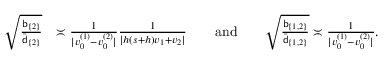<formula> <loc_0><loc_0><loc_500><loc_500>\begin{array} { r l } { \sqrt { \frac { b _ { \{ 2 \} } } { \bar { d } _ { \{ 2 \} } } } } & { \asymp \frac { 1 } { | v _ { 0 } ^ { ( 1 ) } - v _ { 0 } ^ { ( 2 ) } | } \frac { 1 } { | h ( s + h ) v _ { 1 } + v _ { 2 } | } a n d \sqrt { \frac { b _ { \{ 1 , 2 \} } } { \bar { d } _ { \{ 1 , 2 \} } } } \asymp \frac { 1 } { | v _ { 0 } ^ { ( 1 ) } - v _ { 0 } ^ { ( 2 ) } | } . } \end{array}</formula> 